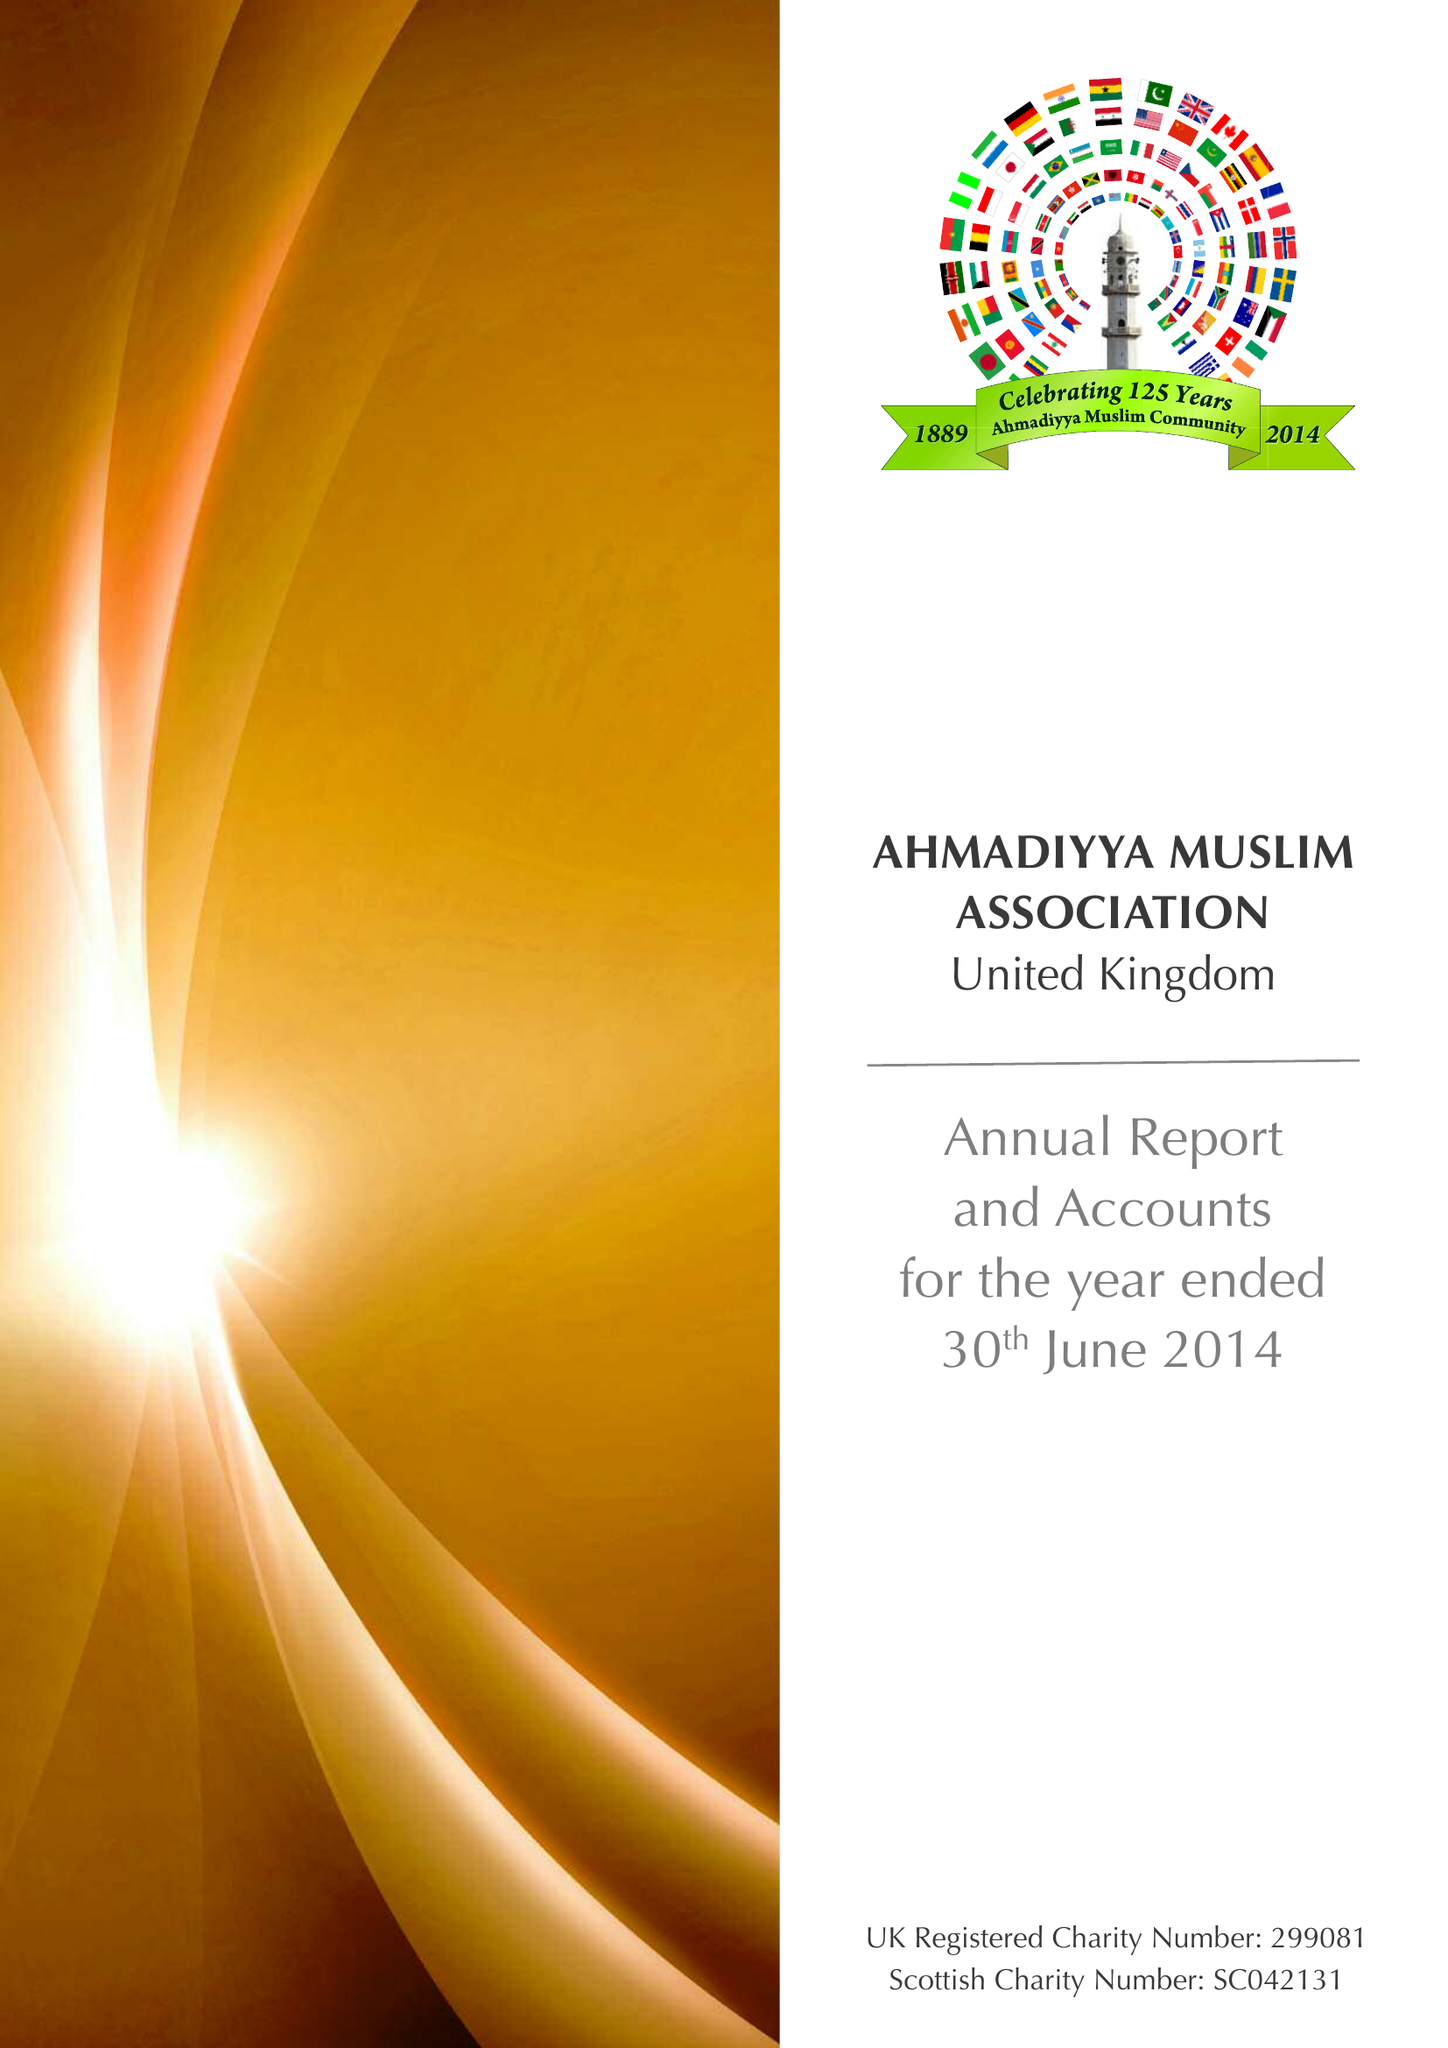What is the value for the address__street_line?
Answer the question using a single word or phrase. 53 MELROSE ROAD 